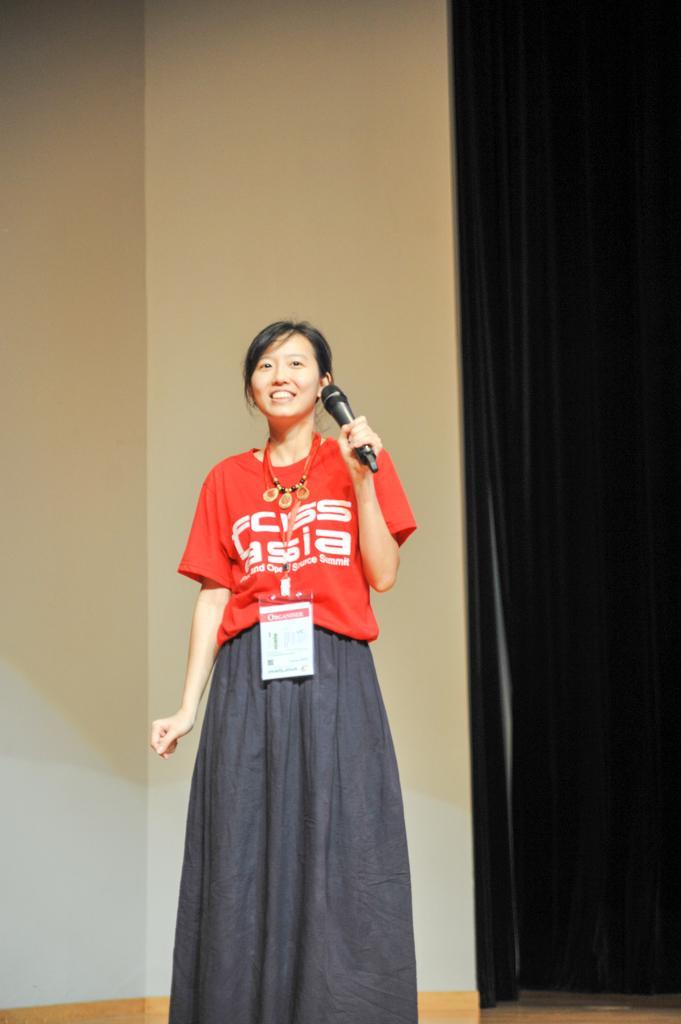Could you give a brief overview of what you see in this image? The woman in red t-shirt holds a mic. She wore an id card. There is a black curtain. 